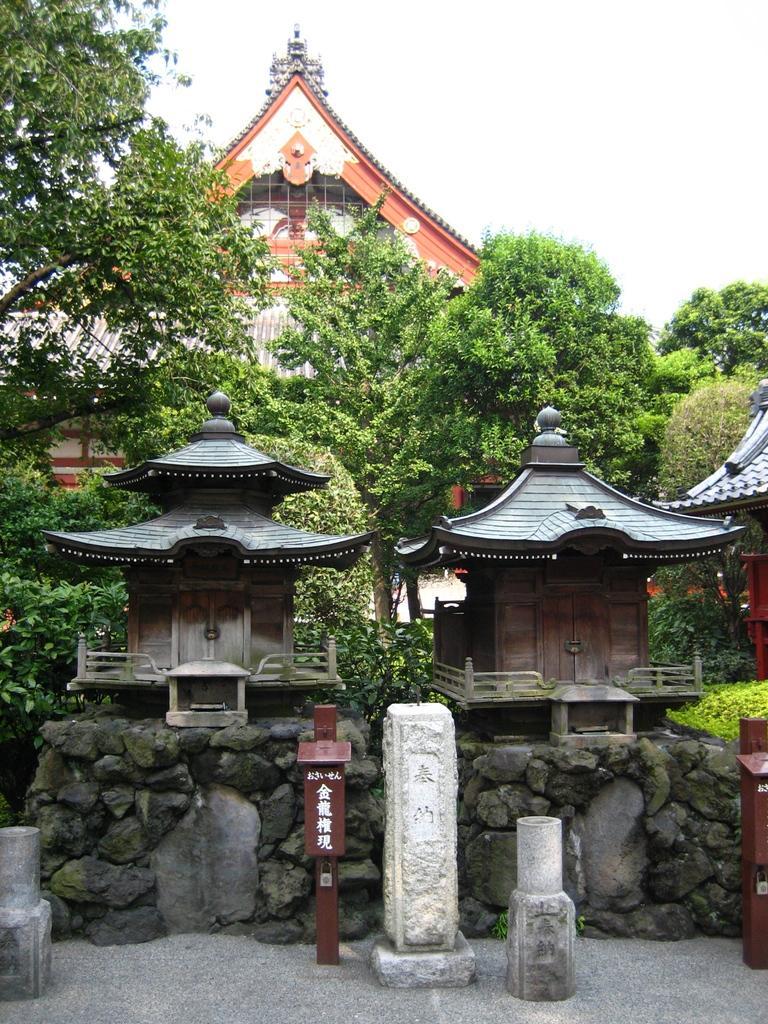Please provide a concise description of this image. In this picture we can see ancient architectures, doors, trees, wall and in the background we can see the sky. 